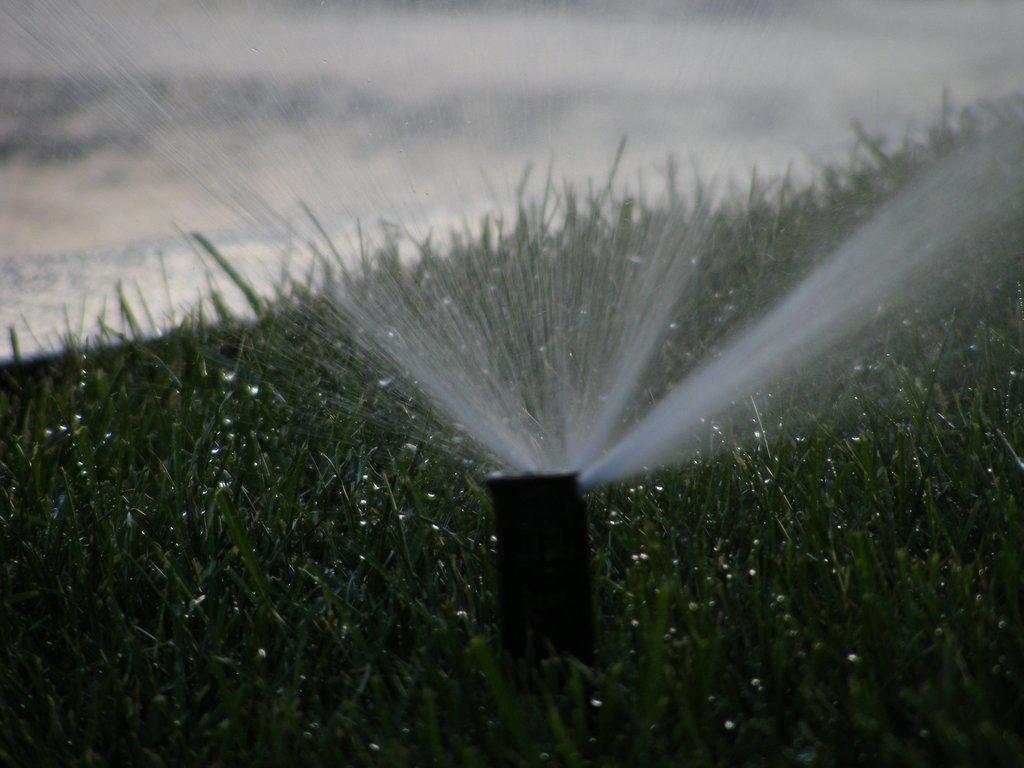Describe this image in one or two sentences. In this picture we can observe a water sprinkler on the ground. There is some grass on the ground. In the background it is completely blur. 